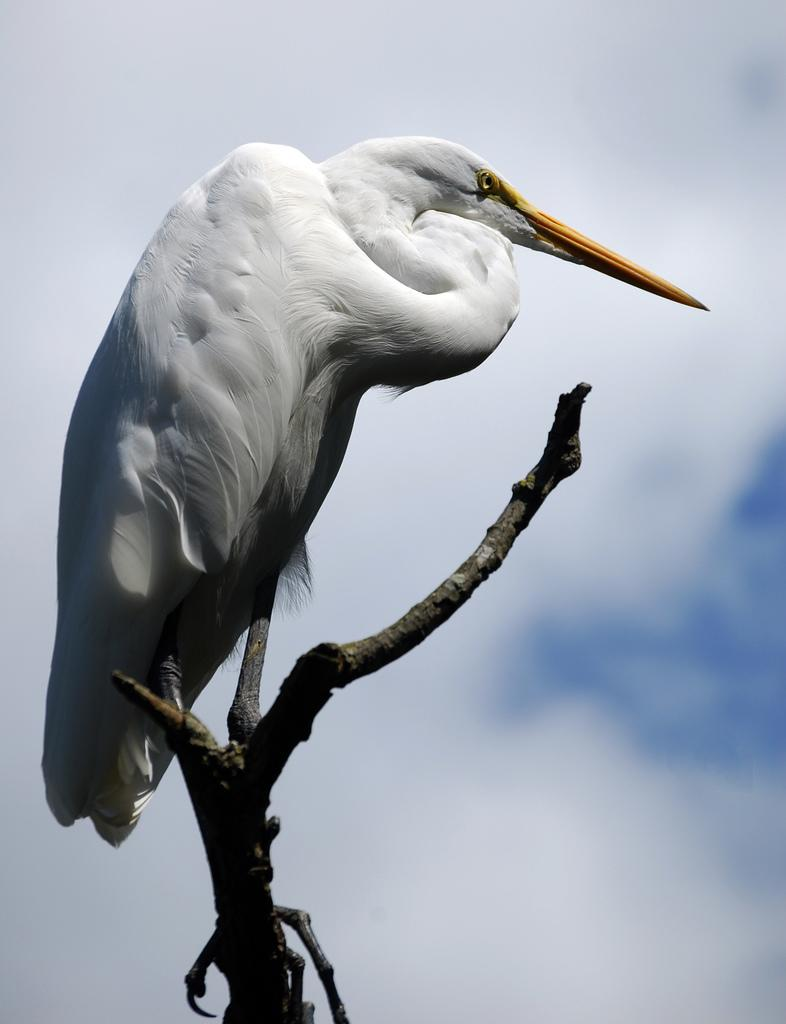What is the main subject of the image? There is a bird on a stem in the image. What can be seen in the background of the image? The sky is visible in the image. What is the condition of the sky in the image? There are clouds in the sky. What historical event is depicted in the image? There is no historical event depicted in the image; it features a bird on a stem with clouds in the sky. What feeling does the image evoke in the viewer? The image does not evoke a specific feeling, as it is a simple depiction of a bird on a stem with clouds in the sky. 